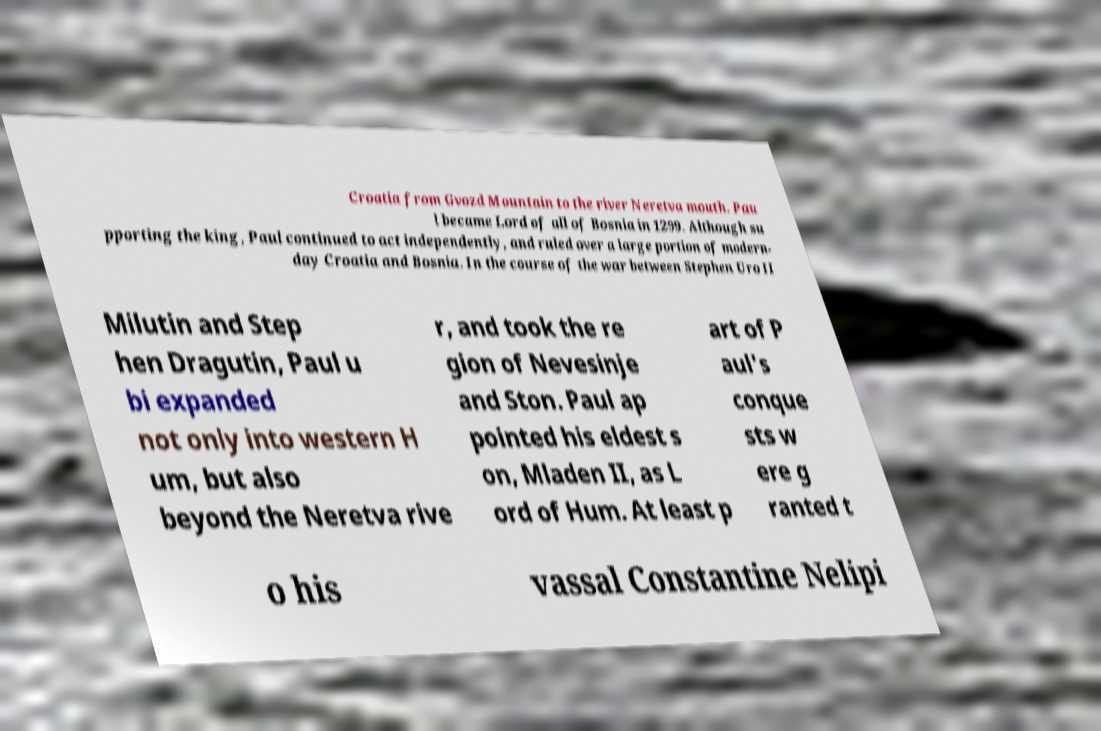I need the written content from this picture converted into text. Can you do that? Croatia from Gvozd Mountain to the river Neretva mouth. Pau l became Lord of all of Bosnia in 1299. Although su pporting the king, Paul continued to act independently, and ruled over a large portion of modern- day Croatia and Bosnia. In the course of the war between Stephen Uro II Milutin and Step hen Dragutin, Paul u bi expanded not only into western H um, but also beyond the Neretva rive r, and took the re gion of Nevesinje and Ston. Paul ap pointed his eldest s on, Mladen II, as L ord of Hum. At least p art of P aul's conque sts w ere g ranted t o his vassal Constantine Nelipi 